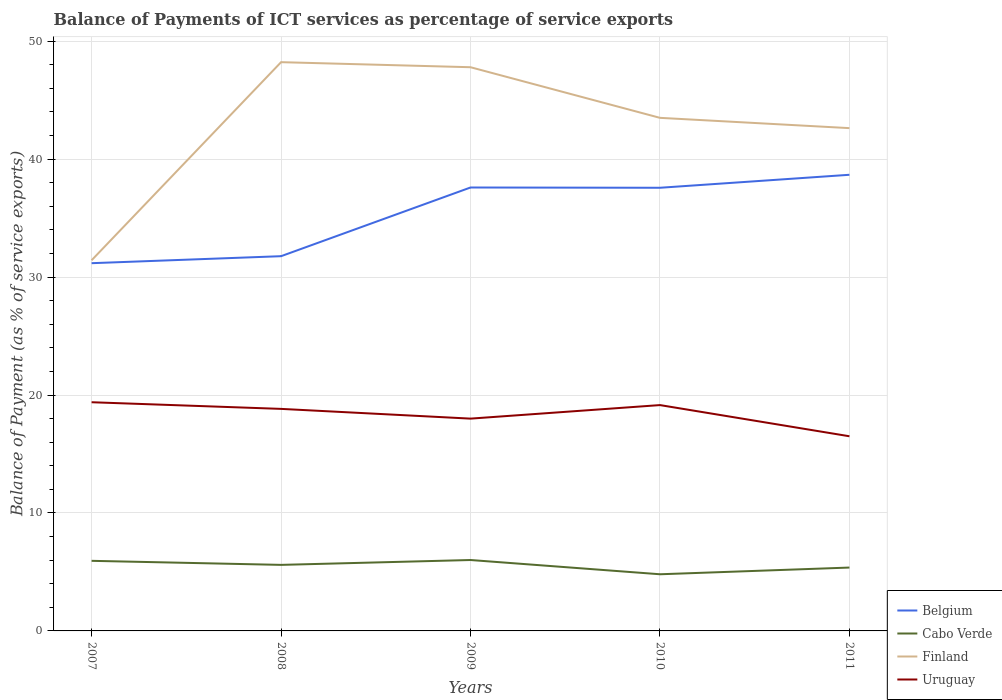How many different coloured lines are there?
Your answer should be very brief. 4. Across all years, what is the maximum balance of payments of ICT services in Belgium?
Offer a terse response. 31.18. What is the total balance of payments of ICT services in Uruguay in the graph?
Your answer should be compact. -0.32. What is the difference between the highest and the second highest balance of payments of ICT services in Uruguay?
Give a very brief answer. 2.89. Is the balance of payments of ICT services in Cabo Verde strictly greater than the balance of payments of ICT services in Uruguay over the years?
Provide a succinct answer. Yes. What is the difference between two consecutive major ticks on the Y-axis?
Provide a short and direct response. 10. Are the values on the major ticks of Y-axis written in scientific E-notation?
Give a very brief answer. No. Does the graph contain any zero values?
Offer a terse response. No. Does the graph contain grids?
Make the answer very short. Yes. How many legend labels are there?
Give a very brief answer. 4. What is the title of the graph?
Ensure brevity in your answer.  Balance of Payments of ICT services as percentage of service exports. Does "Isle of Man" appear as one of the legend labels in the graph?
Keep it short and to the point. No. What is the label or title of the X-axis?
Make the answer very short. Years. What is the label or title of the Y-axis?
Keep it short and to the point. Balance of Payment (as % of service exports). What is the Balance of Payment (as % of service exports) of Belgium in 2007?
Your answer should be compact. 31.18. What is the Balance of Payment (as % of service exports) of Cabo Verde in 2007?
Your answer should be compact. 5.94. What is the Balance of Payment (as % of service exports) in Finland in 2007?
Your answer should be very brief. 31.43. What is the Balance of Payment (as % of service exports) in Uruguay in 2007?
Offer a terse response. 19.39. What is the Balance of Payment (as % of service exports) in Belgium in 2008?
Your answer should be very brief. 31.77. What is the Balance of Payment (as % of service exports) in Cabo Verde in 2008?
Provide a succinct answer. 5.6. What is the Balance of Payment (as % of service exports) in Finland in 2008?
Your response must be concise. 48.22. What is the Balance of Payment (as % of service exports) of Uruguay in 2008?
Give a very brief answer. 18.83. What is the Balance of Payment (as % of service exports) of Belgium in 2009?
Your response must be concise. 37.6. What is the Balance of Payment (as % of service exports) of Cabo Verde in 2009?
Your answer should be very brief. 6.01. What is the Balance of Payment (as % of service exports) in Finland in 2009?
Keep it short and to the point. 47.79. What is the Balance of Payment (as % of service exports) in Uruguay in 2009?
Offer a terse response. 18. What is the Balance of Payment (as % of service exports) in Belgium in 2010?
Provide a succinct answer. 37.57. What is the Balance of Payment (as % of service exports) of Cabo Verde in 2010?
Offer a terse response. 4.8. What is the Balance of Payment (as % of service exports) of Finland in 2010?
Your response must be concise. 43.5. What is the Balance of Payment (as % of service exports) of Uruguay in 2010?
Give a very brief answer. 19.15. What is the Balance of Payment (as % of service exports) of Belgium in 2011?
Keep it short and to the point. 38.68. What is the Balance of Payment (as % of service exports) in Cabo Verde in 2011?
Offer a terse response. 5.37. What is the Balance of Payment (as % of service exports) in Finland in 2011?
Ensure brevity in your answer.  42.63. What is the Balance of Payment (as % of service exports) in Uruguay in 2011?
Your answer should be compact. 16.5. Across all years, what is the maximum Balance of Payment (as % of service exports) in Belgium?
Give a very brief answer. 38.68. Across all years, what is the maximum Balance of Payment (as % of service exports) in Cabo Verde?
Provide a short and direct response. 6.01. Across all years, what is the maximum Balance of Payment (as % of service exports) in Finland?
Ensure brevity in your answer.  48.22. Across all years, what is the maximum Balance of Payment (as % of service exports) of Uruguay?
Offer a very short reply. 19.39. Across all years, what is the minimum Balance of Payment (as % of service exports) in Belgium?
Ensure brevity in your answer.  31.18. Across all years, what is the minimum Balance of Payment (as % of service exports) of Cabo Verde?
Keep it short and to the point. 4.8. Across all years, what is the minimum Balance of Payment (as % of service exports) in Finland?
Provide a short and direct response. 31.43. Across all years, what is the minimum Balance of Payment (as % of service exports) in Uruguay?
Offer a terse response. 16.5. What is the total Balance of Payment (as % of service exports) of Belgium in the graph?
Ensure brevity in your answer.  176.8. What is the total Balance of Payment (as % of service exports) of Cabo Verde in the graph?
Your response must be concise. 27.73. What is the total Balance of Payment (as % of service exports) in Finland in the graph?
Provide a succinct answer. 213.57. What is the total Balance of Payment (as % of service exports) of Uruguay in the graph?
Your answer should be very brief. 91.87. What is the difference between the Balance of Payment (as % of service exports) in Belgium in 2007 and that in 2008?
Provide a short and direct response. -0.59. What is the difference between the Balance of Payment (as % of service exports) in Cabo Verde in 2007 and that in 2008?
Your response must be concise. 0.34. What is the difference between the Balance of Payment (as % of service exports) of Finland in 2007 and that in 2008?
Provide a succinct answer. -16.8. What is the difference between the Balance of Payment (as % of service exports) of Uruguay in 2007 and that in 2008?
Offer a terse response. 0.56. What is the difference between the Balance of Payment (as % of service exports) in Belgium in 2007 and that in 2009?
Keep it short and to the point. -6.42. What is the difference between the Balance of Payment (as % of service exports) of Cabo Verde in 2007 and that in 2009?
Make the answer very short. -0.07. What is the difference between the Balance of Payment (as % of service exports) of Finland in 2007 and that in 2009?
Give a very brief answer. -16.37. What is the difference between the Balance of Payment (as % of service exports) in Uruguay in 2007 and that in 2009?
Your answer should be compact. 1.39. What is the difference between the Balance of Payment (as % of service exports) of Belgium in 2007 and that in 2010?
Ensure brevity in your answer.  -6.39. What is the difference between the Balance of Payment (as % of service exports) of Cabo Verde in 2007 and that in 2010?
Keep it short and to the point. 1.14. What is the difference between the Balance of Payment (as % of service exports) in Finland in 2007 and that in 2010?
Offer a terse response. -12.08. What is the difference between the Balance of Payment (as % of service exports) of Uruguay in 2007 and that in 2010?
Offer a terse response. 0.24. What is the difference between the Balance of Payment (as % of service exports) in Belgium in 2007 and that in 2011?
Make the answer very short. -7.5. What is the difference between the Balance of Payment (as % of service exports) in Cabo Verde in 2007 and that in 2011?
Your response must be concise. 0.57. What is the difference between the Balance of Payment (as % of service exports) of Finland in 2007 and that in 2011?
Offer a terse response. -11.2. What is the difference between the Balance of Payment (as % of service exports) in Uruguay in 2007 and that in 2011?
Offer a terse response. 2.89. What is the difference between the Balance of Payment (as % of service exports) of Belgium in 2008 and that in 2009?
Keep it short and to the point. -5.82. What is the difference between the Balance of Payment (as % of service exports) of Cabo Verde in 2008 and that in 2009?
Provide a succinct answer. -0.41. What is the difference between the Balance of Payment (as % of service exports) of Finland in 2008 and that in 2009?
Provide a short and direct response. 0.43. What is the difference between the Balance of Payment (as % of service exports) in Uruguay in 2008 and that in 2009?
Make the answer very short. 0.83. What is the difference between the Balance of Payment (as % of service exports) of Belgium in 2008 and that in 2010?
Give a very brief answer. -5.8. What is the difference between the Balance of Payment (as % of service exports) of Cabo Verde in 2008 and that in 2010?
Your answer should be compact. 0.8. What is the difference between the Balance of Payment (as % of service exports) in Finland in 2008 and that in 2010?
Your answer should be very brief. 4.72. What is the difference between the Balance of Payment (as % of service exports) in Uruguay in 2008 and that in 2010?
Offer a very short reply. -0.32. What is the difference between the Balance of Payment (as % of service exports) in Belgium in 2008 and that in 2011?
Give a very brief answer. -6.9. What is the difference between the Balance of Payment (as % of service exports) of Cabo Verde in 2008 and that in 2011?
Your answer should be compact. 0.23. What is the difference between the Balance of Payment (as % of service exports) in Finland in 2008 and that in 2011?
Your answer should be very brief. 5.59. What is the difference between the Balance of Payment (as % of service exports) in Uruguay in 2008 and that in 2011?
Ensure brevity in your answer.  2.32. What is the difference between the Balance of Payment (as % of service exports) of Belgium in 2009 and that in 2010?
Provide a short and direct response. 0.02. What is the difference between the Balance of Payment (as % of service exports) of Cabo Verde in 2009 and that in 2010?
Give a very brief answer. 1.21. What is the difference between the Balance of Payment (as % of service exports) in Finland in 2009 and that in 2010?
Your answer should be very brief. 4.29. What is the difference between the Balance of Payment (as % of service exports) of Uruguay in 2009 and that in 2010?
Offer a terse response. -1.15. What is the difference between the Balance of Payment (as % of service exports) of Belgium in 2009 and that in 2011?
Provide a short and direct response. -1.08. What is the difference between the Balance of Payment (as % of service exports) in Cabo Verde in 2009 and that in 2011?
Your answer should be very brief. 0.64. What is the difference between the Balance of Payment (as % of service exports) in Finland in 2009 and that in 2011?
Give a very brief answer. 5.16. What is the difference between the Balance of Payment (as % of service exports) of Uruguay in 2009 and that in 2011?
Ensure brevity in your answer.  1.5. What is the difference between the Balance of Payment (as % of service exports) in Belgium in 2010 and that in 2011?
Provide a succinct answer. -1.1. What is the difference between the Balance of Payment (as % of service exports) of Cabo Verde in 2010 and that in 2011?
Give a very brief answer. -0.57. What is the difference between the Balance of Payment (as % of service exports) in Finland in 2010 and that in 2011?
Offer a very short reply. 0.87. What is the difference between the Balance of Payment (as % of service exports) of Uruguay in 2010 and that in 2011?
Provide a short and direct response. 2.64. What is the difference between the Balance of Payment (as % of service exports) in Belgium in 2007 and the Balance of Payment (as % of service exports) in Cabo Verde in 2008?
Provide a short and direct response. 25.58. What is the difference between the Balance of Payment (as % of service exports) in Belgium in 2007 and the Balance of Payment (as % of service exports) in Finland in 2008?
Make the answer very short. -17.04. What is the difference between the Balance of Payment (as % of service exports) in Belgium in 2007 and the Balance of Payment (as % of service exports) in Uruguay in 2008?
Offer a very short reply. 12.35. What is the difference between the Balance of Payment (as % of service exports) of Cabo Verde in 2007 and the Balance of Payment (as % of service exports) of Finland in 2008?
Your response must be concise. -42.28. What is the difference between the Balance of Payment (as % of service exports) of Cabo Verde in 2007 and the Balance of Payment (as % of service exports) of Uruguay in 2008?
Your answer should be compact. -12.88. What is the difference between the Balance of Payment (as % of service exports) of Finland in 2007 and the Balance of Payment (as % of service exports) of Uruguay in 2008?
Your answer should be compact. 12.6. What is the difference between the Balance of Payment (as % of service exports) in Belgium in 2007 and the Balance of Payment (as % of service exports) in Cabo Verde in 2009?
Your response must be concise. 25.17. What is the difference between the Balance of Payment (as % of service exports) in Belgium in 2007 and the Balance of Payment (as % of service exports) in Finland in 2009?
Your answer should be compact. -16.61. What is the difference between the Balance of Payment (as % of service exports) in Belgium in 2007 and the Balance of Payment (as % of service exports) in Uruguay in 2009?
Provide a succinct answer. 13.18. What is the difference between the Balance of Payment (as % of service exports) in Cabo Verde in 2007 and the Balance of Payment (as % of service exports) in Finland in 2009?
Offer a terse response. -41.85. What is the difference between the Balance of Payment (as % of service exports) in Cabo Verde in 2007 and the Balance of Payment (as % of service exports) in Uruguay in 2009?
Provide a succinct answer. -12.06. What is the difference between the Balance of Payment (as % of service exports) of Finland in 2007 and the Balance of Payment (as % of service exports) of Uruguay in 2009?
Give a very brief answer. 13.43. What is the difference between the Balance of Payment (as % of service exports) in Belgium in 2007 and the Balance of Payment (as % of service exports) in Cabo Verde in 2010?
Your response must be concise. 26.38. What is the difference between the Balance of Payment (as % of service exports) of Belgium in 2007 and the Balance of Payment (as % of service exports) of Finland in 2010?
Make the answer very short. -12.32. What is the difference between the Balance of Payment (as % of service exports) in Belgium in 2007 and the Balance of Payment (as % of service exports) in Uruguay in 2010?
Provide a short and direct response. 12.03. What is the difference between the Balance of Payment (as % of service exports) in Cabo Verde in 2007 and the Balance of Payment (as % of service exports) in Finland in 2010?
Provide a succinct answer. -37.56. What is the difference between the Balance of Payment (as % of service exports) in Cabo Verde in 2007 and the Balance of Payment (as % of service exports) in Uruguay in 2010?
Offer a terse response. -13.21. What is the difference between the Balance of Payment (as % of service exports) of Finland in 2007 and the Balance of Payment (as % of service exports) of Uruguay in 2010?
Your response must be concise. 12.28. What is the difference between the Balance of Payment (as % of service exports) in Belgium in 2007 and the Balance of Payment (as % of service exports) in Cabo Verde in 2011?
Provide a short and direct response. 25.81. What is the difference between the Balance of Payment (as % of service exports) in Belgium in 2007 and the Balance of Payment (as % of service exports) in Finland in 2011?
Offer a very short reply. -11.45. What is the difference between the Balance of Payment (as % of service exports) in Belgium in 2007 and the Balance of Payment (as % of service exports) in Uruguay in 2011?
Keep it short and to the point. 14.68. What is the difference between the Balance of Payment (as % of service exports) in Cabo Verde in 2007 and the Balance of Payment (as % of service exports) in Finland in 2011?
Your answer should be very brief. -36.69. What is the difference between the Balance of Payment (as % of service exports) of Cabo Verde in 2007 and the Balance of Payment (as % of service exports) of Uruguay in 2011?
Offer a terse response. -10.56. What is the difference between the Balance of Payment (as % of service exports) in Finland in 2007 and the Balance of Payment (as % of service exports) in Uruguay in 2011?
Your answer should be very brief. 14.92. What is the difference between the Balance of Payment (as % of service exports) of Belgium in 2008 and the Balance of Payment (as % of service exports) of Cabo Verde in 2009?
Make the answer very short. 25.76. What is the difference between the Balance of Payment (as % of service exports) in Belgium in 2008 and the Balance of Payment (as % of service exports) in Finland in 2009?
Your answer should be very brief. -16.02. What is the difference between the Balance of Payment (as % of service exports) in Belgium in 2008 and the Balance of Payment (as % of service exports) in Uruguay in 2009?
Provide a succinct answer. 13.77. What is the difference between the Balance of Payment (as % of service exports) in Cabo Verde in 2008 and the Balance of Payment (as % of service exports) in Finland in 2009?
Your response must be concise. -42.19. What is the difference between the Balance of Payment (as % of service exports) in Cabo Verde in 2008 and the Balance of Payment (as % of service exports) in Uruguay in 2009?
Your answer should be very brief. -12.4. What is the difference between the Balance of Payment (as % of service exports) in Finland in 2008 and the Balance of Payment (as % of service exports) in Uruguay in 2009?
Provide a succinct answer. 30.22. What is the difference between the Balance of Payment (as % of service exports) of Belgium in 2008 and the Balance of Payment (as % of service exports) of Cabo Verde in 2010?
Ensure brevity in your answer.  26.97. What is the difference between the Balance of Payment (as % of service exports) in Belgium in 2008 and the Balance of Payment (as % of service exports) in Finland in 2010?
Keep it short and to the point. -11.73. What is the difference between the Balance of Payment (as % of service exports) of Belgium in 2008 and the Balance of Payment (as % of service exports) of Uruguay in 2010?
Your answer should be compact. 12.62. What is the difference between the Balance of Payment (as % of service exports) in Cabo Verde in 2008 and the Balance of Payment (as % of service exports) in Finland in 2010?
Offer a terse response. -37.9. What is the difference between the Balance of Payment (as % of service exports) of Cabo Verde in 2008 and the Balance of Payment (as % of service exports) of Uruguay in 2010?
Offer a terse response. -13.55. What is the difference between the Balance of Payment (as % of service exports) of Finland in 2008 and the Balance of Payment (as % of service exports) of Uruguay in 2010?
Keep it short and to the point. 29.07. What is the difference between the Balance of Payment (as % of service exports) in Belgium in 2008 and the Balance of Payment (as % of service exports) in Cabo Verde in 2011?
Keep it short and to the point. 26.4. What is the difference between the Balance of Payment (as % of service exports) of Belgium in 2008 and the Balance of Payment (as % of service exports) of Finland in 2011?
Provide a short and direct response. -10.86. What is the difference between the Balance of Payment (as % of service exports) of Belgium in 2008 and the Balance of Payment (as % of service exports) of Uruguay in 2011?
Your response must be concise. 15.27. What is the difference between the Balance of Payment (as % of service exports) of Cabo Verde in 2008 and the Balance of Payment (as % of service exports) of Finland in 2011?
Keep it short and to the point. -37.03. What is the difference between the Balance of Payment (as % of service exports) of Cabo Verde in 2008 and the Balance of Payment (as % of service exports) of Uruguay in 2011?
Provide a succinct answer. -10.9. What is the difference between the Balance of Payment (as % of service exports) in Finland in 2008 and the Balance of Payment (as % of service exports) in Uruguay in 2011?
Your answer should be very brief. 31.72. What is the difference between the Balance of Payment (as % of service exports) in Belgium in 2009 and the Balance of Payment (as % of service exports) in Cabo Verde in 2010?
Ensure brevity in your answer.  32.79. What is the difference between the Balance of Payment (as % of service exports) of Belgium in 2009 and the Balance of Payment (as % of service exports) of Finland in 2010?
Provide a succinct answer. -5.91. What is the difference between the Balance of Payment (as % of service exports) in Belgium in 2009 and the Balance of Payment (as % of service exports) in Uruguay in 2010?
Keep it short and to the point. 18.45. What is the difference between the Balance of Payment (as % of service exports) of Cabo Verde in 2009 and the Balance of Payment (as % of service exports) of Finland in 2010?
Offer a very short reply. -37.49. What is the difference between the Balance of Payment (as % of service exports) in Cabo Verde in 2009 and the Balance of Payment (as % of service exports) in Uruguay in 2010?
Your answer should be compact. -13.14. What is the difference between the Balance of Payment (as % of service exports) of Finland in 2009 and the Balance of Payment (as % of service exports) of Uruguay in 2010?
Keep it short and to the point. 28.65. What is the difference between the Balance of Payment (as % of service exports) of Belgium in 2009 and the Balance of Payment (as % of service exports) of Cabo Verde in 2011?
Make the answer very short. 32.22. What is the difference between the Balance of Payment (as % of service exports) in Belgium in 2009 and the Balance of Payment (as % of service exports) in Finland in 2011?
Ensure brevity in your answer.  -5.03. What is the difference between the Balance of Payment (as % of service exports) of Belgium in 2009 and the Balance of Payment (as % of service exports) of Uruguay in 2011?
Your response must be concise. 21.09. What is the difference between the Balance of Payment (as % of service exports) in Cabo Verde in 2009 and the Balance of Payment (as % of service exports) in Finland in 2011?
Ensure brevity in your answer.  -36.62. What is the difference between the Balance of Payment (as % of service exports) of Cabo Verde in 2009 and the Balance of Payment (as % of service exports) of Uruguay in 2011?
Make the answer very short. -10.49. What is the difference between the Balance of Payment (as % of service exports) of Finland in 2009 and the Balance of Payment (as % of service exports) of Uruguay in 2011?
Make the answer very short. 31.29. What is the difference between the Balance of Payment (as % of service exports) in Belgium in 2010 and the Balance of Payment (as % of service exports) in Cabo Verde in 2011?
Keep it short and to the point. 32.2. What is the difference between the Balance of Payment (as % of service exports) of Belgium in 2010 and the Balance of Payment (as % of service exports) of Finland in 2011?
Offer a very short reply. -5.06. What is the difference between the Balance of Payment (as % of service exports) in Belgium in 2010 and the Balance of Payment (as % of service exports) in Uruguay in 2011?
Your answer should be compact. 21.07. What is the difference between the Balance of Payment (as % of service exports) of Cabo Verde in 2010 and the Balance of Payment (as % of service exports) of Finland in 2011?
Give a very brief answer. -37.83. What is the difference between the Balance of Payment (as % of service exports) in Cabo Verde in 2010 and the Balance of Payment (as % of service exports) in Uruguay in 2011?
Offer a very short reply. -11.7. What is the difference between the Balance of Payment (as % of service exports) in Finland in 2010 and the Balance of Payment (as % of service exports) in Uruguay in 2011?
Provide a succinct answer. 27. What is the average Balance of Payment (as % of service exports) of Belgium per year?
Provide a short and direct response. 35.36. What is the average Balance of Payment (as % of service exports) of Cabo Verde per year?
Your answer should be compact. 5.55. What is the average Balance of Payment (as % of service exports) of Finland per year?
Offer a terse response. 42.72. What is the average Balance of Payment (as % of service exports) of Uruguay per year?
Your answer should be compact. 18.37. In the year 2007, what is the difference between the Balance of Payment (as % of service exports) of Belgium and Balance of Payment (as % of service exports) of Cabo Verde?
Your answer should be compact. 25.24. In the year 2007, what is the difference between the Balance of Payment (as % of service exports) of Belgium and Balance of Payment (as % of service exports) of Finland?
Your answer should be compact. -0.25. In the year 2007, what is the difference between the Balance of Payment (as % of service exports) of Belgium and Balance of Payment (as % of service exports) of Uruguay?
Ensure brevity in your answer.  11.79. In the year 2007, what is the difference between the Balance of Payment (as % of service exports) in Cabo Verde and Balance of Payment (as % of service exports) in Finland?
Offer a very short reply. -25.48. In the year 2007, what is the difference between the Balance of Payment (as % of service exports) of Cabo Verde and Balance of Payment (as % of service exports) of Uruguay?
Your response must be concise. -13.45. In the year 2007, what is the difference between the Balance of Payment (as % of service exports) in Finland and Balance of Payment (as % of service exports) in Uruguay?
Offer a very short reply. 12.04. In the year 2008, what is the difference between the Balance of Payment (as % of service exports) of Belgium and Balance of Payment (as % of service exports) of Cabo Verde?
Offer a very short reply. 26.17. In the year 2008, what is the difference between the Balance of Payment (as % of service exports) in Belgium and Balance of Payment (as % of service exports) in Finland?
Your answer should be compact. -16.45. In the year 2008, what is the difference between the Balance of Payment (as % of service exports) in Belgium and Balance of Payment (as % of service exports) in Uruguay?
Give a very brief answer. 12.95. In the year 2008, what is the difference between the Balance of Payment (as % of service exports) in Cabo Verde and Balance of Payment (as % of service exports) in Finland?
Make the answer very short. -42.62. In the year 2008, what is the difference between the Balance of Payment (as % of service exports) of Cabo Verde and Balance of Payment (as % of service exports) of Uruguay?
Offer a very short reply. -13.23. In the year 2008, what is the difference between the Balance of Payment (as % of service exports) of Finland and Balance of Payment (as % of service exports) of Uruguay?
Provide a succinct answer. 29.4. In the year 2009, what is the difference between the Balance of Payment (as % of service exports) in Belgium and Balance of Payment (as % of service exports) in Cabo Verde?
Make the answer very short. 31.58. In the year 2009, what is the difference between the Balance of Payment (as % of service exports) in Belgium and Balance of Payment (as % of service exports) in Finland?
Offer a very short reply. -10.2. In the year 2009, what is the difference between the Balance of Payment (as % of service exports) in Belgium and Balance of Payment (as % of service exports) in Uruguay?
Give a very brief answer. 19.6. In the year 2009, what is the difference between the Balance of Payment (as % of service exports) of Cabo Verde and Balance of Payment (as % of service exports) of Finland?
Give a very brief answer. -41.78. In the year 2009, what is the difference between the Balance of Payment (as % of service exports) in Cabo Verde and Balance of Payment (as % of service exports) in Uruguay?
Provide a short and direct response. -11.99. In the year 2009, what is the difference between the Balance of Payment (as % of service exports) of Finland and Balance of Payment (as % of service exports) of Uruguay?
Provide a short and direct response. 29.79. In the year 2010, what is the difference between the Balance of Payment (as % of service exports) of Belgium and Balance of Payment (as % of service exports) of Cabo Verde?
Give a very brief answer. 32.77. In the year 2010, what is the difference between the Balance of Payment (as % of service exports) of Belgium and Balance of Payment (as % of service exports) of Finland?
Your response must be concise. -5.93. In the year 2010, what is the difference between the Balance of Payment (as % of service exports) of Belgium and Balance of Payment (as % of service exports) of Uruguay?
Provide a short and direct response. 18.43. In the year 2010, what is the difference between the Balance of Payment (as % of service exports) of Cabo Verde and Balance of Payment (as % of service exports) of Finland?
Ensure brevity in your answer.  -38.7. In the year 2010, what is the difference between the Balance of Payment (as % of service exports) of Cabo Verde and Balance of Payment (as % of service exports) of Uruguay?
Offer a terse response. -14.34. In the year 2010, what is the difference between the Balance of Payment (as % of service exports) of Finland and Balance of Payment (as % of service exports) of Uruguay?
Provide a succinct answer. 24.35. In the year 2011, what is the difference between the Balance of Payment (as % of service exports) of Belgium and Balance of Payment (as % of service exports) of Cabo Verde?
Your response must be concise. 33.3. In the year 2011, what is the difference between the Balance of Payment (as % of service exports) in Belgium and Balance of Payment (as % of service exports) in Finland?
Your response must be concise. -3.95. In the year 2011, what is the difference between the Balance of Payment (as % of service exports) in Belgium and Balance of Payment (as % of service exports) in Uruguay?
Provide a succinct answer. 22.17. In the year 2011, what is the difference between the Balance of Payment (as % of service exports) of Cabo Verde and Balance of Payment (as % of service exports) of Finland?
Offer a terse response. -37.26. In the year 2011, what is the difference between the Balance of Payment (as % of service exports) in Cabo Verde and Balance of Payment (as % of service exports) in Uruguay?
Ensure brevity in your answer.  -11.13. In the year 2011, what is the difference between the Balance of Payment (as % of service exports) in Finland and Balance of Payment (as % of service exports) in Uruguay?
Offer a very short reply. 26.13. What is the ratio of the Balance of Payment (as % of service exports) of Belgium in 2007 to that in 2008?
Ensure brevity in your answer.  0.98. What is the ratio of the Balance of Payment (as % of service exports) of Cabo Verde in 2007 to that in 2008?
Your response must be concise. 1.06. What is the ratio of the Balance of Payment (as % of service exports) in Finland in 2007 to that in 2008?
Your response must be concise. 0.65. What is the ratio of the Balance of Payment (as % of service exports) in Uruguay in 2007 to that in 2008?
Your answer should be very brief. 1.03. What is the ratio of the Balance of Payment (as % of service exports) of Belgium in 2007 to that in 2009?
Give a very brief answer. 0.83. What is the ratio of the Balance of Payment (as % of service exports) of Cabo Verde in 2007 to that in 2009?
Your response must be concise. 0.99. What is the ratio of the Balance of Payment (as % of service exports) in Finland in 2007 to that in 2009?
Offer a terse response. 0.66. What is the ratio of the Balance of Payment (as % of service exports) in Uruguay in 2007 to that in 2009?
Your response must be concise. 1.08. What is the ratio of the Balance of Payment (as % of service exports) in Belgium in 2007 to that in 2010?
Provide a short and direct response. 0.83. What is the ratio of the Balance of Payment (as % of service exports) of Cabo Verde in 2007 to that in 2010?
Your answer should be very brief. 1.24. What is the ratio of the Balance of Payment (as % of service exports) in Finland in 2007 to that in 2010?
Your answer should be very brief. 0.72. What is the ratio of the Balance of Payment (as % of service exports) in Uruguay in 2007 to that in 2010?
Ensure brevity in your answer.  1.01. What is the ratio of the Balance of Payment (as % of service exports) of Belgium in 2007 to that in 2011?
Provide a succinct answer. 0.81. What is the ratio of the Balance of Payment (as % of service exports) of Cabo Verde in 2007 to that in 2011?
Provide a succinct answer. 1.11. What is the ratio of the Balance of Payment (as % of service exports) of Finland in 2007 to that in 2011?
Offer a very short reply. 0.74. What is the ratio of the Balance of Payment (as % of service exports) in Uruguay in 2007 to that in 2011?
Your answer should be compact. 1.17. What is the ratio of the Balance of Payment (as % of service exports) of Belgium in 2008 to that in 2009?
Keep it short and to the point. 0.85. What is the ratio of the Balance of Payment (as % of service exports) of Cabo Verde in 2008 to that in 2009?
Offer a terse response. 0.93. What is the ratio of the Balance of Payment (as % of service exports) of Uruguay in 2008 to that in 2009?
Provide a succinct answer. 1.05. What is the ratio of the Balance of Payment (as % of service exports) in Belgium in 2008 to that in 2010?
Provide a short and direct response. 0.85. What is the ratio of the Balance of Payment (as % of service exports) in Cabo Verde in 2008 to that in 2010?
Your response must be concise. 1.17. What is the ratio of the Balance of Payment (as % of service exports) in Finland in 2008 to that in 2010?
Provide a succinct answer. 1.11. What is the ratio of the Balance of Payment (as % of service exports) in Uruguay in 2008 to that in 2010?
Your answer should be compact. 0.98. What is the ratio of the Balance of Payment (as % of service exports) of Belgium in 2008 to that in 2011?
Make the answer very short. 0.82. What is the ratio of the Balance of Payment (as % of service exports) in Cabo Verde in 2008 to that in 2011?
Provide a succinct answer. 1.04. What is the ratio of the Balance of Payment (as % of service exports) of Finland in 2008 to that in 2011?
Provide a short and direct response. 1.13. What is the ratio of the Balance of Payment (as % of service exports) in Uruguay in 2008 to that in 2011?
Your answer should be compact. 1.14. What is the ratio of the Balance of Payment (as % of service exports) of Cabo Verde in 2009 to that in 2010?
Offer a very short reply. 1.25. What is the ratio of the Balance of Payment (as % of service exports) in Finland in 2009 to that in 2010?
Your response must be concise. 1.1. What is the ratio of the Balance of Payment (as % of service exports) of Uruguay in 2009 to that in 2010?
Ensure brevity in your answer.  0.94. What is the ratio of the Balance of Payment (as % of service exports) in Belgium in 2009 to that in 2011?
Ensure brevity in your answer.  0.97. What is the ratio of the Balance of Payment (as % of service exports) of Cabo Verde in 2009 to that in 2011?
Ensure brevity in your answer.  1.12. What is the ratio of the Balance of Payment (as % of service exports) of Finland in 2009 to that in 2011?
Your answer should be compact. 1.12. What is the ratio of the Balance of Payment (as % of service exports) of Uruguay in 2009 to that in 2011?
Offer a terse response. 1.09. What is the ratio of the Balance of Payment (as % of service exports) of Belgium in 2010 to that in 2011?
Provide a succinct answer. 0.97. What is the ratio of the Balance of Payment (as % of service exports) of Cabo Verde in 2010 to that in 2011?
Provide a succinct answer. 0.89. What is the ratio of the Balance of Payment (as % of service exports) in Finland in 2010 to that in 2011?
Your response must be concise. 1.02. What is the ratio of the Balance of Payment (as % of service exports) in Uruguay in 2010 to that in 2011?
Your answer should be very brief. 1.16. What is the difference between the highest and the second highest Balance of Payment (as % of service exports) of Belgium?
Keep it short and to the point. 1.08. What is the difference between the highest and the second highest Balance of Payment (as % of service exports) of Cabo Verde?
Your answer should be very brief. 0.07. What is the difference between the highest and the second highest Balance of Payment (as % of service exports) in Finland?
Make the answer very short. 0.43. What is the difference between the highest and the second highest Balance of Payment (as % of service exports) in Uruguay?
Ensure brevity in your answer.  0.24. What is the difference between the highest and the lowest Balance of Payment (as % of service exports) of Belgium?
Your answer should be compact. 7.5. What is the difference between the highest and the lowest Balance of Payment (as % of service exports) in Cabo Verde?
Your answer should be very brief. 1.21. What is the difference between the highest and the lowest Balance of Payment (as % of service exports) in Finland?
Provide a short and direct response. 16.8. What is the difference between the highest and the lowest Balance of Payment (as % of service exports) of Uruguay?
Your answer should be compact. 2.89. 